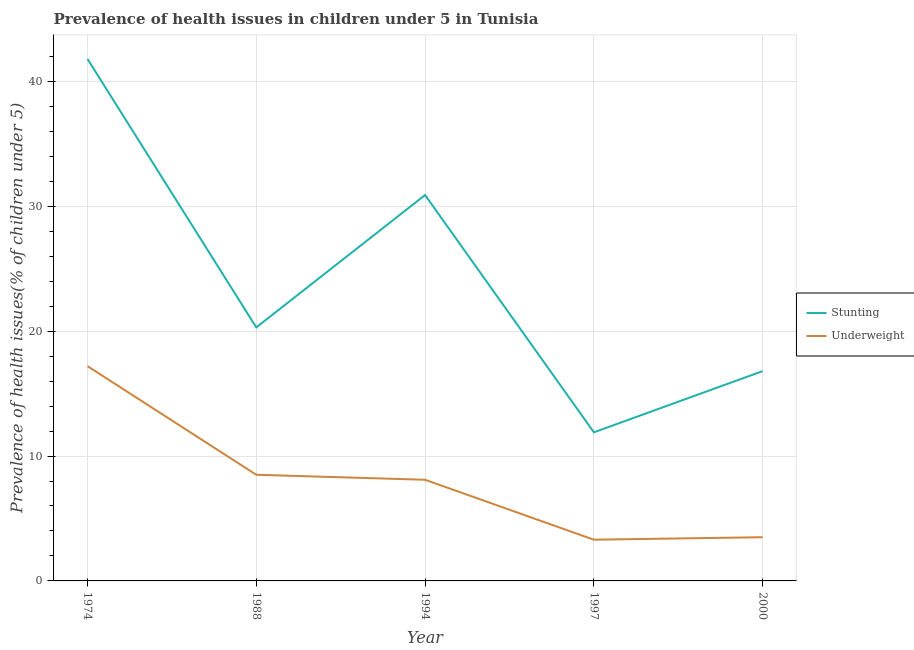How many different coloured lines are there?
Offer a very short reply. 2. Does the line corresponding to percentage of stunted children intersect with the line corresponding to percentage of underweight children?
Your answer should be compact. No. What is the percentage of stunted children in 1994?
Keep it short and to the point. 30.9. Across all years, what is the maximum percentage of stunted children?
Your response must be concise. 41.8. Across all years, what is the minimum percentage of stunted children?
Give a very brief answer. 11.9. In which year was the percentage of underweight children maximum?
Give a very brief answer. 1974. In which year was the percentage of underweight children minimum?
Offer a very short reply. 1997. What is the total percentage of stunted children in the graph?
Keep it short and to the point. 121.7. What is the difference between the percentage of underweight children in 1988 and that in 1997?
Make the answer very short. 5.2. What is the difference between the percentage of stunted children in 1994 and the percentage of underweight children in 1997?
Ensure brevity in your answer.  27.6. What is the average percentage of underweight children per year?
Your answer should be compact. 8.12. In the year 2000, what is the difference between the percentage of underweight children and percentage of stunted children?
Offer a very short reply. -13.3. What is the ratio of the percentage of stunted children in 1988 to that in 2000?
Offer a terse response. 1.21. Is the percentage of underweight children in 1974 less than that in 1997?
Make the answer very short. No. What is the difference between the highest and the second highest percentage of underweight children?
Offer a terse response. 8.7. What is the difference between the highest and the lowest percentage of stunted children?
Ensure brevity in your answer.  29.9. Is the sum of the percentage of stunted children in 1974 and 1988 greater than the maximum percentage of underweight children across all years?
Keep it short and to the point. Yes. Does the percentage of stunted children monotonically increase over the years?
Your answer should be very brief. No. Is the percentage of stunted children strictly greater than the percentage of underweight children over the years?
Offer a very short reply. Yes. What is the difference between two consecutive major ticks on the Y-axis?
Provide a succinct answer. 10. Does the graph contain any zero values?
Offer a terse response. No. Does the graph contain grids?
Make the answer very short. Yes. Where does the legend appear in the graph?
Offer a terse response. Center right. What is the title of the graph?
Your answer should be very brief. Prevalence of health issues in children under 5 in Tunisia. What is the label or title of the Y-axis?
Provide a succinct answer. Prevalence of health issues(% of children under 5). What is the Prevalence of health issues(% of children under 5) of Stunting in 1974?
Ensure brevity in your answer.  41.8. What is the Prevalence of health issues(% of children under 5) of Underweight in 1974?
Your answer should be compact. 17.2. What is the Prevalence of health issues(% of children under 5) in Stunting in 1988?
Ensure brevity in your answer.  20.3. What is the Prevalence of health issues(% of children under 5) of Underweight in 1988?
Provide a short and direct response. 8.5. What is the Prevalence of health issues(% of children under 5) in Stunting in 1994?
Offer a terse response. 30.9. What is the Prevalence of health issues(% of children under 5) of Underweight in 1994?
Provide a succinct answer. 8.1. What is the Prevalence of health issues(% of children under 5) in Stunting in 1997?
Offer a very short reply. 11.9. What is the Prevalence of health issues(% of children under 5) of Underweight in 1997?
Offer a terse response. 3.3. What is the Prevalence of health issues(% of children under 5) of Stunting in 2000?
Provide a short and direct response. 16.8. Across all years, what is the maximum Prevalence of health issues(% of children under 5) of Stunting?
Provide a short and direct response. 41.8. Across all years, what is the maximum Prevalence of health issues(% of children under 5) in Underweight?
Offer a very short reply. 17.2. Across all years, what is the minimum Prevalence of health issues(% of children under 5) in Stunting?
Your response must be concise. 11.9. Across all years, what is the minimum Prevalence of health issues(% of children under 5) of Underweight?
Provide a succinct answer. 3.3. What is the total Prevalence of health issues(% of children under 5) in Stunting in the graph?
Make the answer very short. 121.7. What is the total Prevalence of health issues(% of children under 5) in Underweight in the graph?
Offer a terse response. 40.6. What is the difference between the Prevalence of health issues(% of children under 5) of Underweight in 1974 and that in 1988?
Keep it short and to the point. 8.7. What is the difference between the Prevalence of health issues(% of children under 5) of Stunting in 1974 and that in 1994?
Offer a terse response. 10.9. What is the difference between the Prevalence of health issues(% of children under 5) of Stunting in 1974 and that in 1997?
Offer a terse response. 29.9. What is the difference between the Prevalence of health issues(% of children under 5) in Underweight in 1974 and that in 1997?
Make the answer very short. 13.9. What is the difference between the Prevalence of health issues(% of children under 5) in Underweight in 1974 and that in 2000?
Keep it short and to the point. 13.7. What is the difference between the Prevalence of health issues(% of children under 5) of Stunting in 1988 and that in 1997?
Your answer should be very brief. 8.4. What is the difference between the Prevalence of health issues(% of children under 5) of Underweight in 1988 and that in 2000?
Your answer should be compact. 5. What is the difference between the Prevalence of health issues(% of children under 5) of Underweight in 1994 and that in 1997?
Provide a short and direct response. 4.8. What is the difference between the Prevalence of health issues(% of children under 5) of Stunting in 1997 and that in 2000?
Provide a succinct answer. -4.9. What is the difference between the Prevalence of health issues(% of children under 5) of Underweight in 1997 and that in 2000?
Provide a succinct answer. -0.2. What is the difference between the Prevalence of health issues(% of children under 5) of Stunting in 1974 and the Prevalence of health issues(% of children under 5) of Underweight in 1988?
Offer a terse response. 33.3. What is the difference between the Prevalence of health issues(% of children under 5) of Stunting in 1974 and the Prevalence of health issues(% of children under 5) of Underweight in 1994?
Your response must be concise. 33.7. What is the difference between the Prevalence of health issues(% of children under 5) in Stunting in 1974 and the Prevalence of health issues(% of children under 5) in Underweight in 1997?
Provide a succinct answer. 38.5. What is the difference between the Prevalence of health issues(% of children under 5) of Stunting in 1974 and the Prevalence of health issues(% of children under 5) of Underweight in 2000?
Ensure brevity in your answer.  38.3. What is the difference between the Prevalence of health issues(% of children under 5) of Stunting in 1988 and the Prevalence of health issues(% of children under 5) of Underweight in 1997?
Your response must be concise. 17. What is the difference between the Prevalence of health issues(% of children under 5) of Stunting in 1994 and the Prevalence of health issues(% of children under 5) of Underweight in 1997?
Give a very brief answer. 27.6. What is the difference between the Prevalence of health issues(% of children under 5) in Stunting in 1994 and the Prevalence of health issues(% of children under 5) in Underweight in 2000?
Ensure brevity in your answer.  27.4. What is the average Prevalence of health issues(% of children under 5) of Stunting per year?
Give a very brief answer. 24.34. What is the average Prevalence of health issues(% of children under 5) of Underweight per year?
Offer a very short reply. 8.12. In the year 1974, what is the difference between the Prevalence of health issues(% of children under 5) of Stunting and Prevalence of health issues(% of children under 5) of Underweight?
Your answer should be compact. 24.6. In the year 1994, what is the difference between the Prevalence of health issues(% of children under 5) in Stunting and Prevalence of health issues(% of children under 5) in Underweight?
Your response must be concise. 22.8. In the year 1997, what is the difference between the Prevalence of health issues(% of children under 5) of Stunting and Prevalence of health issues(% of children under 5) of Underweight?
Your response must be concise. 8.6. What is the ratio of the Prevalence of health issues(% of children under 5) in Stunting in 1974 to that in 1988?
Offer a terse response. 2.06. What is the ratio of the Prevalence of health issues(% of children under 5) in Underweight in 1974 to that in 1988?
Provide a succinct answer. 2.02. What is the ratio of the Prevalence of health issues(% of children under 5) of Stunting in 1974 to that in 1994?
Your answer should be compact. 1.35. What is the ratio of the Prevalence of health issues(% of children under 5) of Underweight in 1974 to that in 1994?
Offer a very short reply. 2.12. What is the ratio of the Prevalence of health issues(% of children under 5) in Stunting in 1974 to that in 1997?
Provide a succinct answer. 3.51. What is the ratio of the Prevalence of health issues(% of children under 5) in Underweight in 1974 to that in 1997?
Your answer should be very brief. 5.21. What is the ratio of the Prevalence of health issues(% of children under 5) in Stunting in 1974 to that in 2000?
Your response must be concise. 2.49. What is the ratio of the Prevalence of health issues(% of children under 5) of Underweight in 1974 to that in 2000?
Provide a short and direct response. 4.91. What is the ratio of the Prevalence of health issues(% of children under 5) of Stunting in 1988 to that in 1994?
Your response must be concise. 0.66. What is the ratio of the Prevalence of health issues(% of children under 5) in Underweight in 1988 to that in 1994?
Your answer should be compact. 1.05. What is the ratio of the Prevalence of health issues(% of children under 5) in Stunting in 1988 to that in 1997?
Offer a very short reply. 1.71. What is the ratio of the Prevalence of health issues(% of children under 5) of Underweight in 1988 to that in 1997?
Make the answer very short. 2.58. What is the ratio of the Prevalence of health issues(% of children under 5) of Stunting in 1988 to that in 2000?
Give a very brief answer. 1.21. What is the ratio of the Prevalence of health issues(% of children under 5) of Underweight in 1988 to that in 2000?
Make the answer very short. 2.43. What is the ratio of the Prevalence of health issues(% of children under 5) in Stunting in 1994 to that in 1997?
Give a very brief answer. 2.6. What is the ratio of the Prevalence of health issues(% of children under 5) in Underweight in 1994 to that in 1997?
Provide a succinct answer. 2.45. What is the ratio of the Prevalence of health issues(% of children under 5) of Stunting in 1994 to that in 2000?
Offer a very short reply. 1.84. What is the ratio of the Prevalence of health issues(% of children under 5) of Underweight in 1994 to that in 2000?
Provide a short and direct response. 2.31. What is the ratio of the Prevalence of health issues(% of children under 5) in Stunting in 1997 to that in 2000?
Your answer should be very brief. 0.71. What is the ratio of the Prevalence of health issues(% of children under 5) in Underweight in 1997 to that in 2000?
Your answer should be compact. 0.94. What is the difference between the highest and the second highest Prevalence of health issues(% of children under 5) of Stunting?
Provide a succinct answer. 10.9. What is the difference between the highest and the lowest Prevalence of health issues(% of children under 5) of Stunting?
Offer a terse response. 29.9. What is the difference between the highest and the lowest Prevalence of health issues(% of children under 5) of Underweight?
Your answer should be compact. 13.9. 